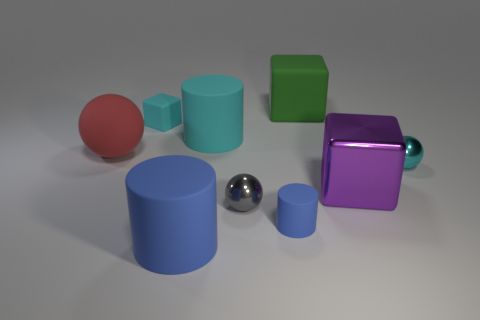There is a matte cylinder that is the same color as the small rubber cube; what is its size?
Make the answer very short. Large. Does the cyan cube have the same size as the cyan matte cylinder?
Offer a very short reply. No. There is a metallic thing that is the same size as the green cube; what is its color?
Keep it short and to the point. Purple. Is the size of the red matte thing the same as the cyan object right of the purple metallic thing?
Give a very brief answer. No. How many metallic spheres have the same color as the tiny rubber cube?
Offer a very short reply. 1. What number of things are either big yellow metal blocks or small objects that are to the left of the big purple metal cube?
Give a very brief answer. 3. There is a cylinder behind the red ball; is it the same size as the green thing on the left side of the tiny cyan sphere?
Keep it short and to the point. Yes. Is there a tiny purple thing that has the same material as the purple block?
Give a very brief answer. No. The purple thing is what shape?
Ensure brevity in your answer.  Cube. What is the shape of the small metal object that is on the left side of the matte thing that is behind the small cube?
Offer a very short reply. Sphere. 